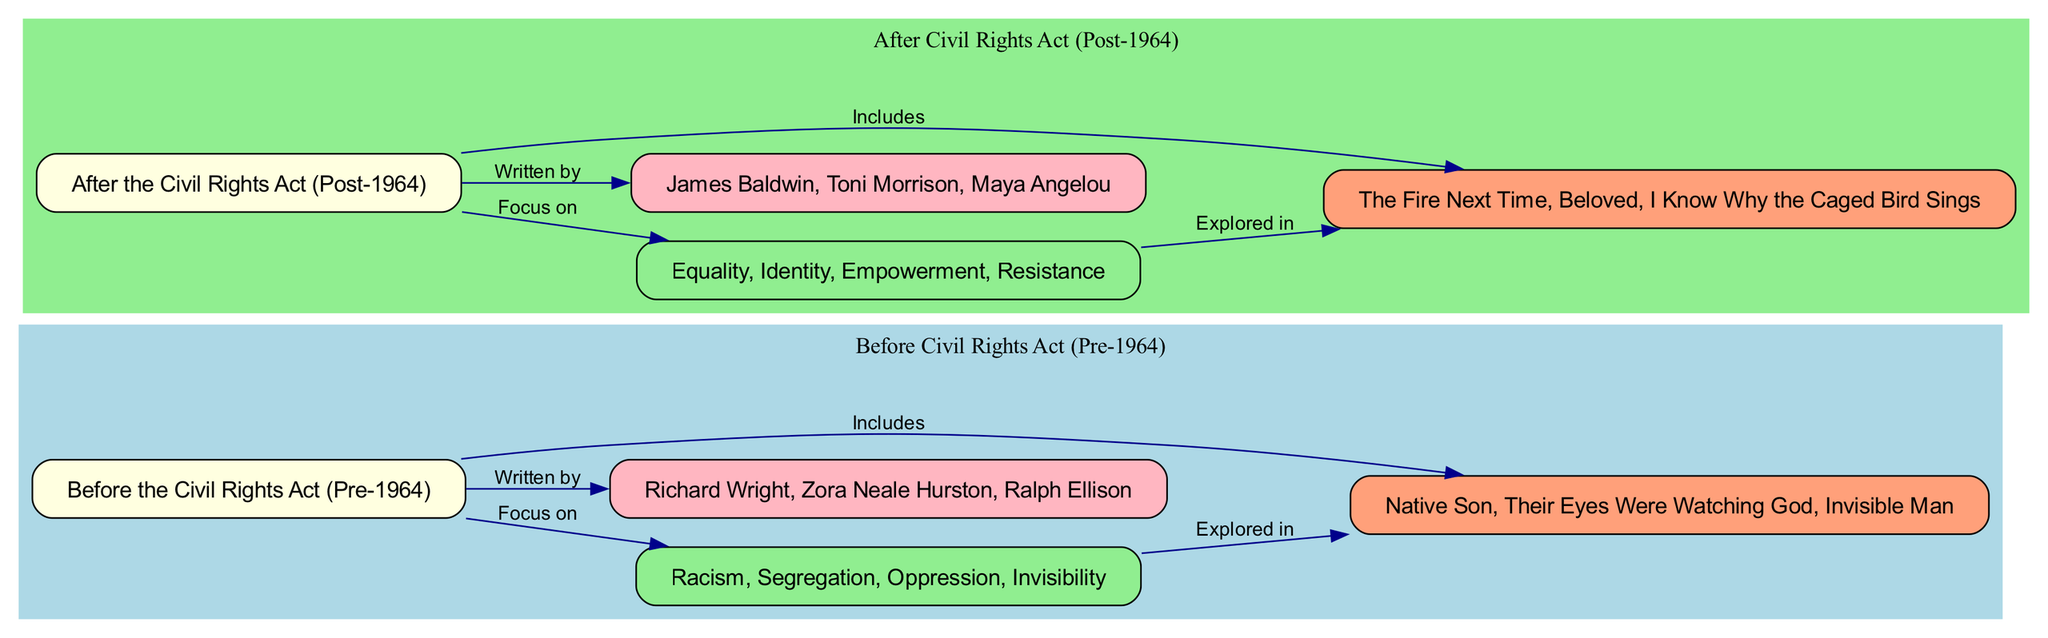What are the common themes explored in literature before 1964? The diagram indicates that the common themes before the Civil Rights Act (Pre-1964) include racism, segregation, oppression, and invisibility. This information can be found in the "Common Themes (Pre-1964)" node, which directly connects from the "Before the Civil Rights Act (Pre-1964)" node.
Answer: Racism, segregation, oppression, invisibility Who are some prominent authors featured in the literature after 1964? The "Prominent Authors (Post-1964)" node lists the authors James Baldwin, Toni Morrison, and Maya Angelou. This information connects from the "After the Civil Rights Act (Post-1964)" node, which helps us identify key literary figures from this period.
Answer: James Baldwin, Toni Morrison, Maya Angelou Which notable work is associated with literature before the Civil Rights Act? The diagram shows the notable works before 1964 include "Native Son", "Their Eyes Were Watching God", and "Invisible Man". This information is under the "Notable Works (Pre-1964)" node linked to the corresponding theme node, providing specific examples of literature from this era.
Answer: Native Son, Their Eyes Were Watching God, Invisible Man Which themes are highlighted in the literature following the Civil Rights Act? According to the diagram, the themes after 1964 focus on equality, identity, empowerment, and resistance. This is found in the "Common Themes (Post-1964)" node that connects from the "After the Civil Rights Act (Post-1964)" node, indicating a shift in thematic focus.
Answer: Equality, identity, empowerment, resistance How many edges are there connecting the themes to the notable works in literature before 1964? The diagram shows one edge connecting the "Common Themes (Pre-1964)" node to the "Notable Works (Pre-1964)" node. This relationship can be identified in the edge details, indicating that there is a direct mapping from themes to specific works of literature.
Answer: 1 What is the relationship type between the "Before the Civil Rights Act" node and the "Prominent Authors (Pre-1964)" node? The diagram indicates that the relationship is labeled "Written by". This relationship shows how the literature from the Pre-1964 era is represented by the noted authors connecting these two nodes.
Answer: Written by Which notable work is written by authors prominent after the Civil Rights Act? The diagram outlines that "Beloved" is one of the notable works post-1964. It's part of the "Notable Works (Post-1964)" node, illustrating the significant contributions of recent authors to literature.
Answer: Beloved What are the characteristics of literature after 1964? The "Characteristics of literature after 1964" are described in the "After the Civil Rights Act (Post-1964)" node, reflecting a change in focus and context for literary works following the Act. This node leads to further detailed themes explored in that period.
Answer: Characteristics of literature after 1964 How many total nodes are presented in the section for literature before 1964? The diagram shows there are four nodes in the section representing literature before 1964, which include "Before the Civil Rights Act", "Common Themes (Pre-1964)", "Prominent Authors (Pre-1964)", and "Notable Works (Pre-1964)". Counting these gives the total number.
Answer: 4 